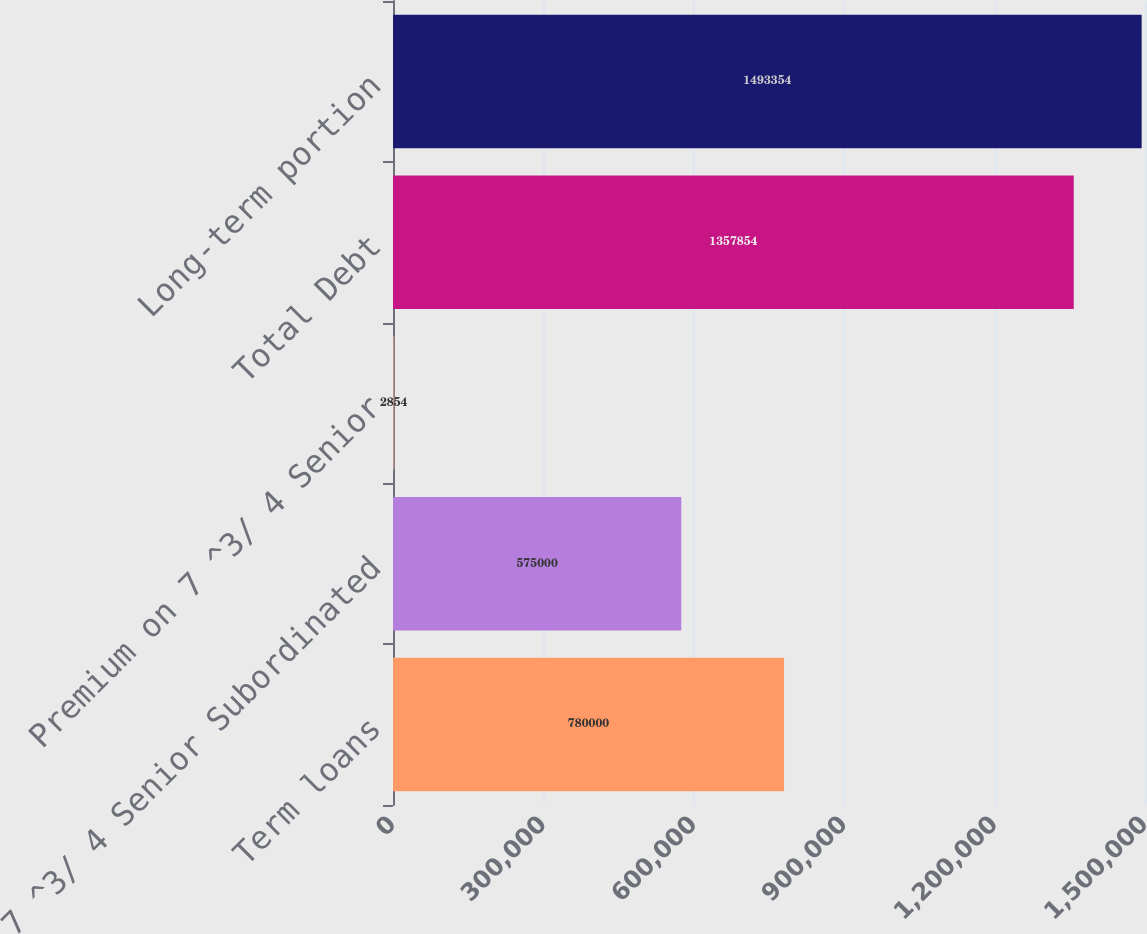Convert chart to OTSL. <chart><loc_0><loc_0><loc_500><loc_500><bar_chart><fcel>Term loans<fcel>7 ^3/ 4 Senior Subordinated<fcel>Premium on 7 ^3/ 4 Senior<fcel>Total Debt<fcel>Long-term portion<nl><fcel>780000<fcel>575000<fcel>2854<fcel>1.35785e+06<fcel>1.49335e+06<nl></chart> 